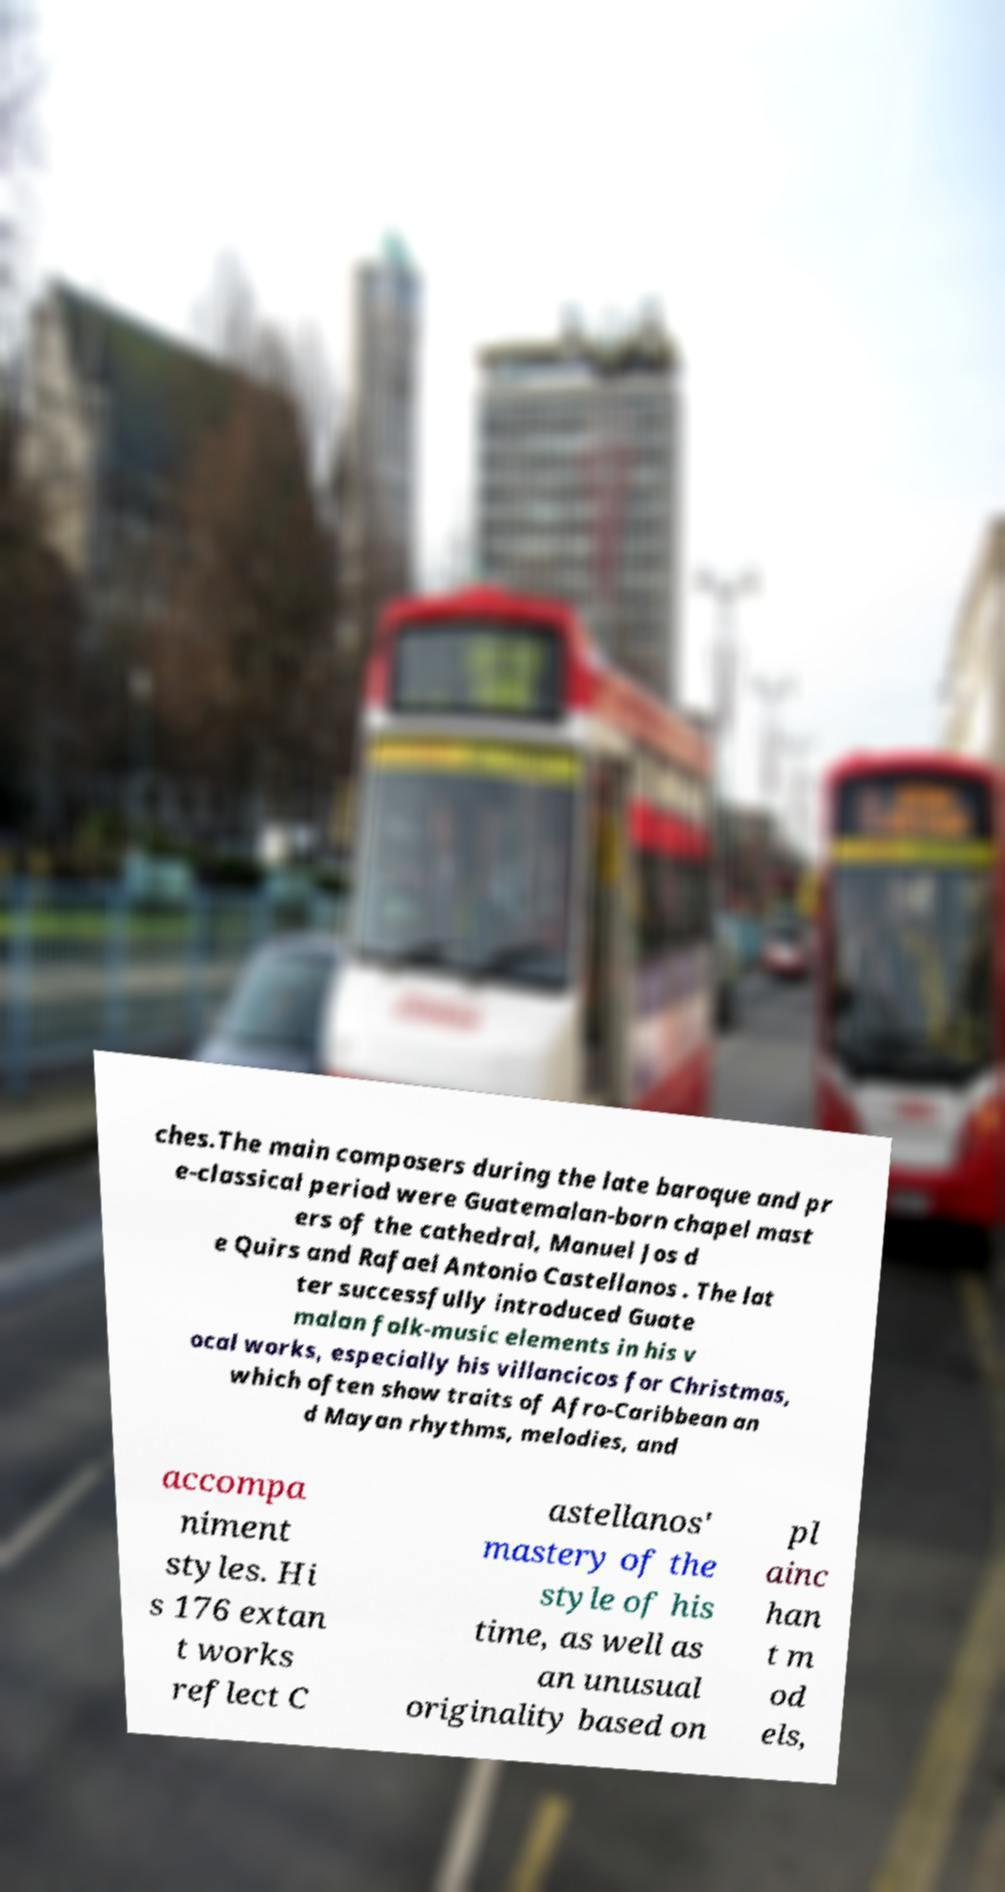I need the written content from this picture converted into text. Can you do that? ches.The main composers during the late baroque and pr e-classical period were Guatemalan-born chapel mast ers of the cathedral, Manuel Jos d e Quirs and Rafael Antonio Castellanos . The lat ter successfully introduced Guate malan folk-music elements in his v ocal works, especially his villancicos for Christmas, which often show traits of Afro-Caribbean an d Mayan rhythms, melodies, and accompa niment styles. Hi s 176 extan t works reflect C astellanos' mastery of the style of his time, as well as an unusual originality based on pl ainc han t m od els, 